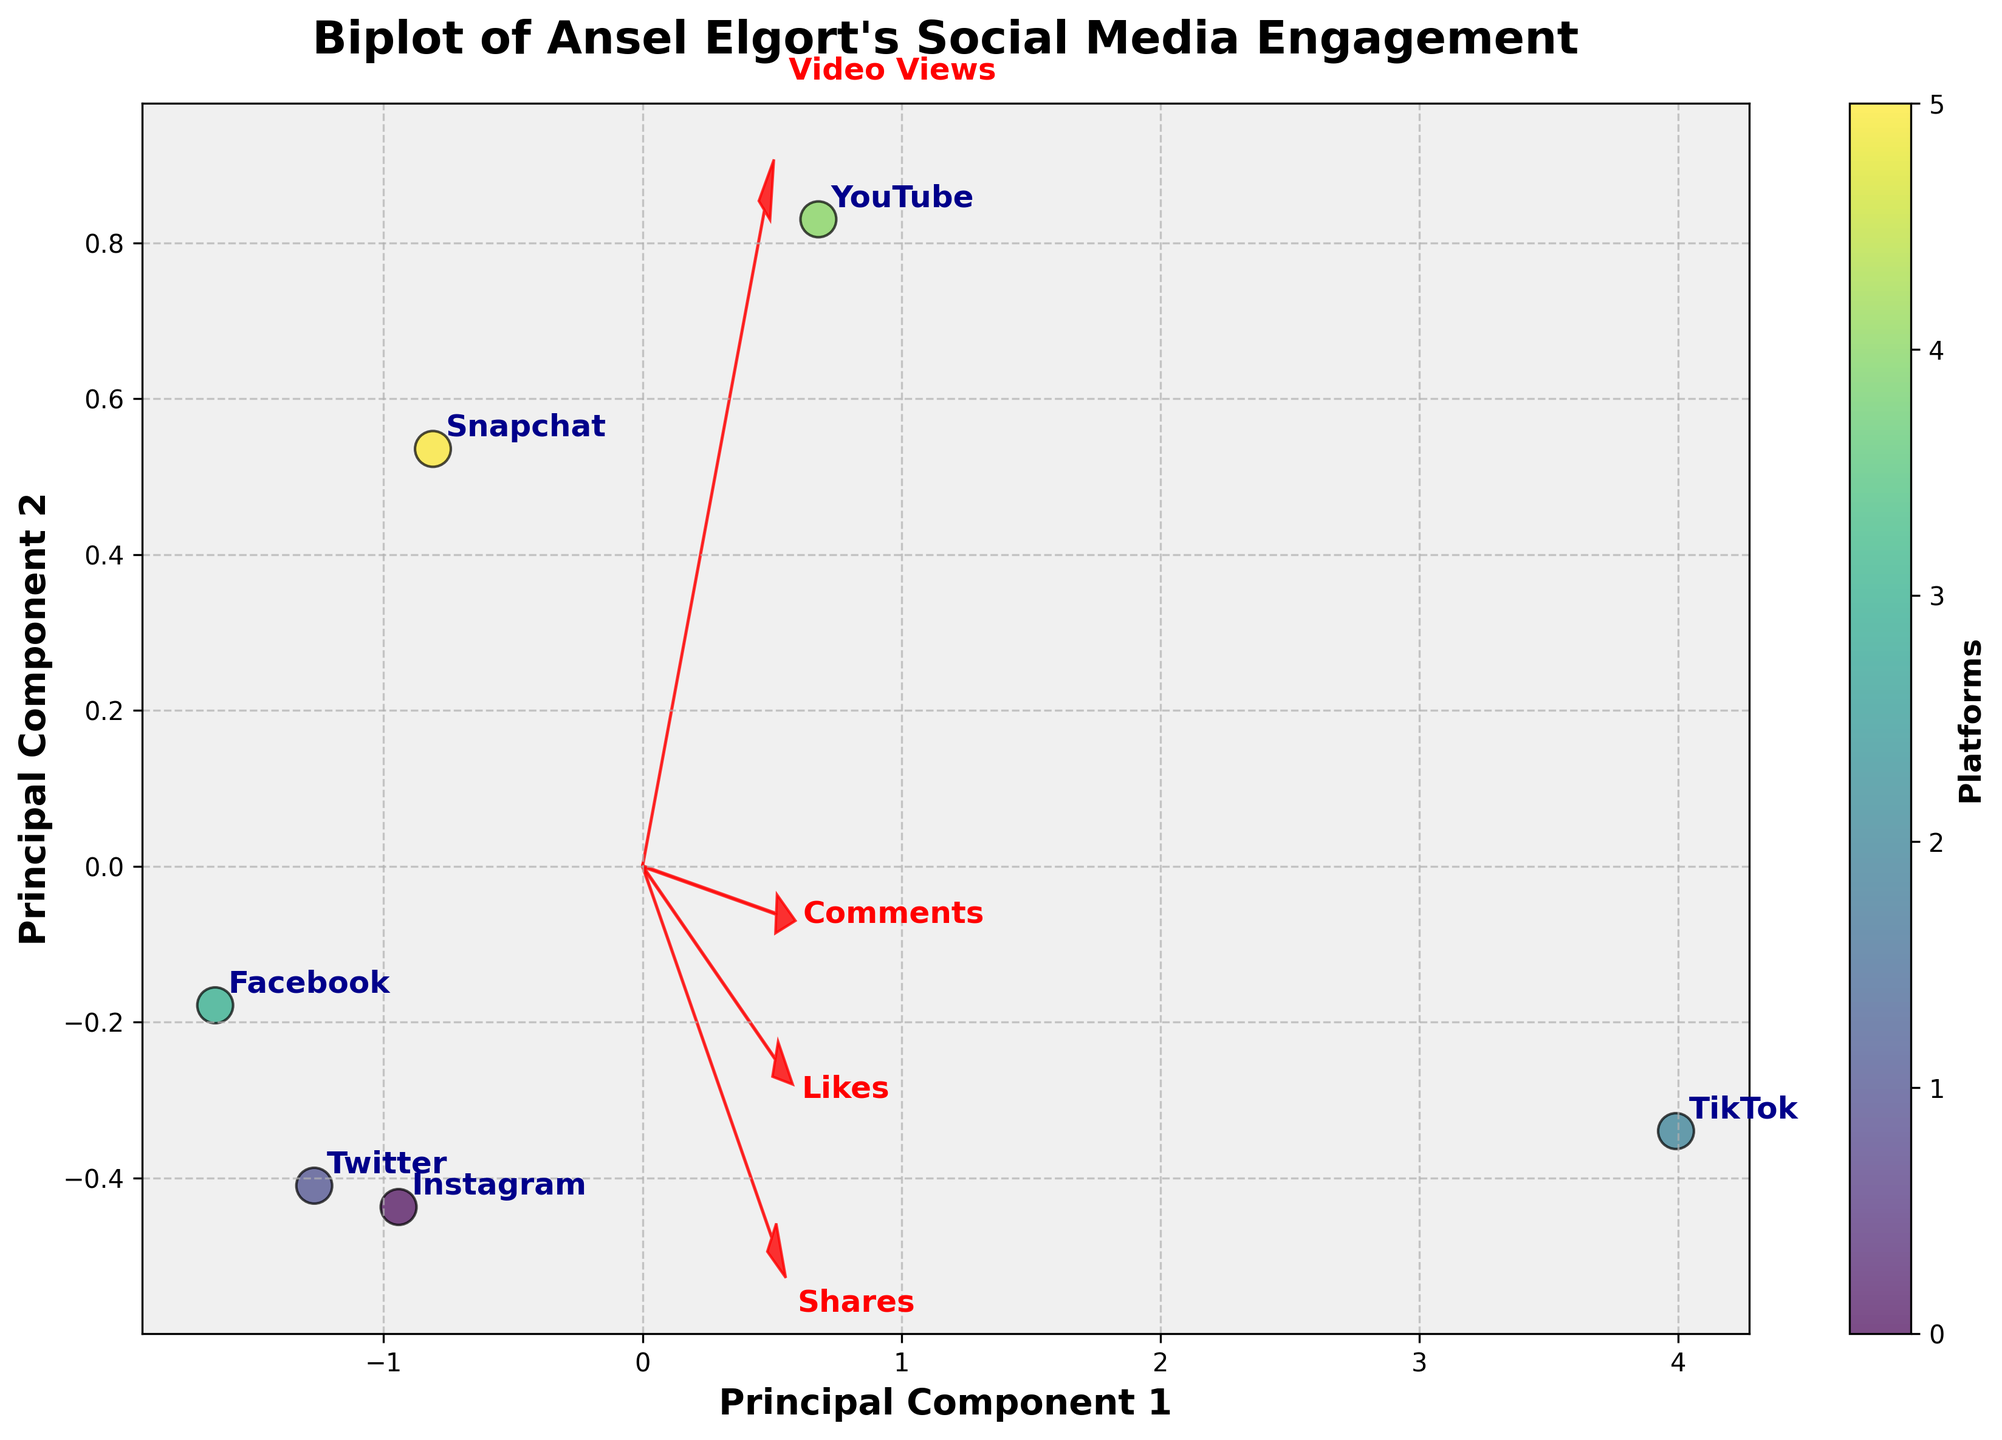What is the title of the biplot? The title of the biplot is usually found at the top and provides an overview of what the plot represents. The title reads "Biplot of Ansel Elgort's Social Media Engagement."
Answer: Biplot of Ansel Elgort's Social Media Engagement How many social media platforms are analyzed in the biplot? By counting the distinct annotations or colored points representing each platform on the biplot, we can determine the number of platforms. There are six platforms labeled on the biplot.
Answer: 6 Which platform has the highest engagement in terms of video views? We can determine this by looking at the position along the "Video Views" vector (red arrow) and noting which platform is furthest along this direction. TikTok is the furthest, indicating it has the highest video views.
Answer: TikTok How do Instagram and Twitter compare in terms of "Likes"? Determine the positions of Instagram and Twitter relative to the "Likes" vector. Instagram is closer to the direction of the "Likes" arrow than Twitter, meaning Instagram has more likes.
Answer: Instagram has more likes than Twitter Which feature contributes most significantly to the first principal component (PC1)? By analyzing the length and direction of the feature vectors relative to the PC1 axis, we can see that the "Video Views" vector has the longest projection onto the PC1 axis, indicating it significantly contributes the most.
Answer: Video Views What can we infer about Snapchat's performance in video views compared to other platforms? By observing Snapchat’s position concerning the "Video Views" vector, we can see it is moderately far along this direction but not as far as TikTok or YouTube, suggesting it has considerable, but not top, video views performance.
Answer: Moderate video views, not as high as TikTok or YouTube Which two platforms are most similar in engagement metrics? Look for platforms positioned closely together on the biplot. Instagram and Snapchat are positioned close to each other, indicating similar engagement metrics.
Answer: Instagram and Snapchat What is the principal component that explains the maximum variance in the engagement metrics? The first principal component (PC1) usually explains the maximum variance in PCA. The x-axis on the biplot corresponds to PC1, so it explains the maximum variance.
Answer: PC1 How do YouTube and Facebook compare in terms of "Comments"? Examine their positions relative to the "Comments" vector. YouTube is positioned closer to the direction indicated by the "Comments" arrow, meaning YouTube sees more comments than Facebook.
Answer: YouTube has more comments than Facebook What is the cumulative explained variance of the first two principal components? PCA plots often display the variance percentage explained by each component in the axis labels or legend; summing these for PC1 and PC2 gives the cumulative explained variance. Without specific values provided, general biplot structure entails approximately 70-80%.
Answer: Approximately 70-80% 